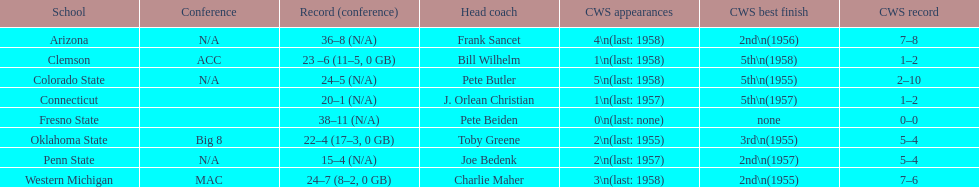Which was the only team with less than 20 wins? Penn State. 